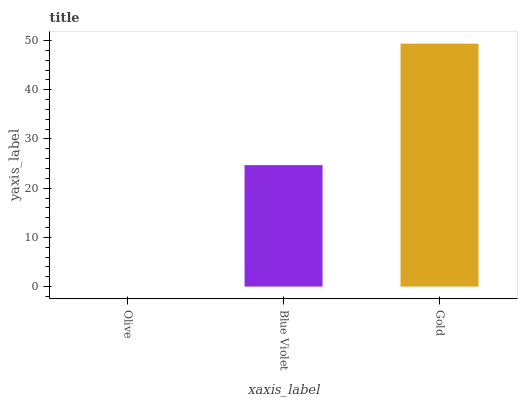Is Olive the minimum?
Answer yes or no. Yes. Is Gold the maximum?
Answer yes or no. Yes. Is Blue Violet the minimum?
Answer yes or no. No. Is Blue Violet the maximum?
Answer yes or no. No. Is Blue Violet greater than Olive?
Answer yes or no. Yes. Is Olive less than Blue Violet?
Answer yes or no. Yes. Is Olive greater than Blue Violet?
Answer yes or no. No. Is Blue Violet less than Olive?
Answer yes or no. No. Is Blue Violet the high median?
Answer yes or no. Yes. Is Blue Violet the low median?
Answer yes or no. Yes. Is Olive the high median?
Answer yes or no. No. Is Olive the low median?
Answer yes or no. No. 